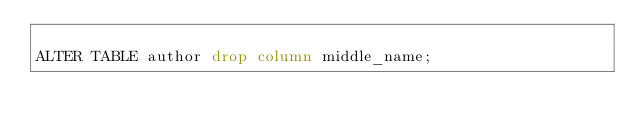Convert code to text. <code><loc_0><loc_0><loc_500><loc_500><_SQL_>
ALTER TABLE author drop column middle_name;</code> 